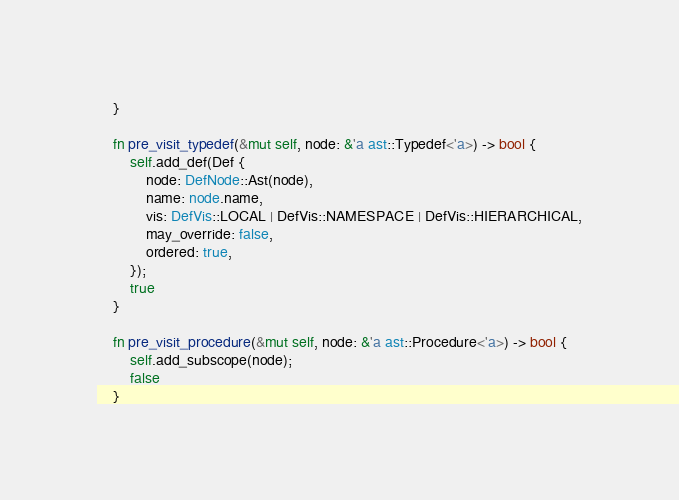<code> <loc_0><loc_0><loc_500><loc_500><_Rust_>    }

    fn pre_visit_typedef(&mut self, node: &'a ast::Typedef<'a>) -> bool {
        self.add_def(Def {
            node: DefNode::Ast(node),
            name: node.name,
            vis: DefVis::LOCAL | DefVis::NAMESPACE | DefVis::HIERARCHICAL,
            may_override: false,
            ordered: true,
        });
        true
    }

    fn pre_visit_procedure(&mut self, node: &'a ast::Procedure<'a>) -> bool {
        self.add_subscope(node);
        false
    }
</code> 